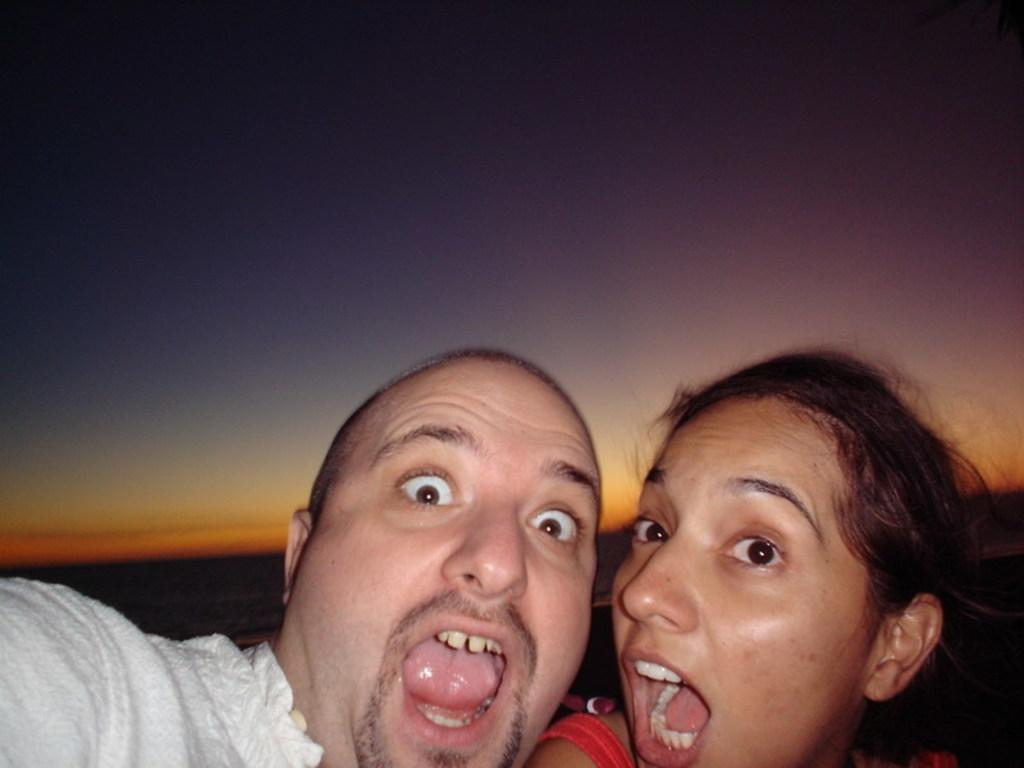Who are the people in the image? There is a man and a woman in the image. What are the man and woman doing in the image? The man and woman are opening their mouths. What can be seen in the background of the image? There is a sky visible in the background of the image. What type of territory is being claimed by the cub in the image? There is no cub present in the image, so no territory is being claimed. 